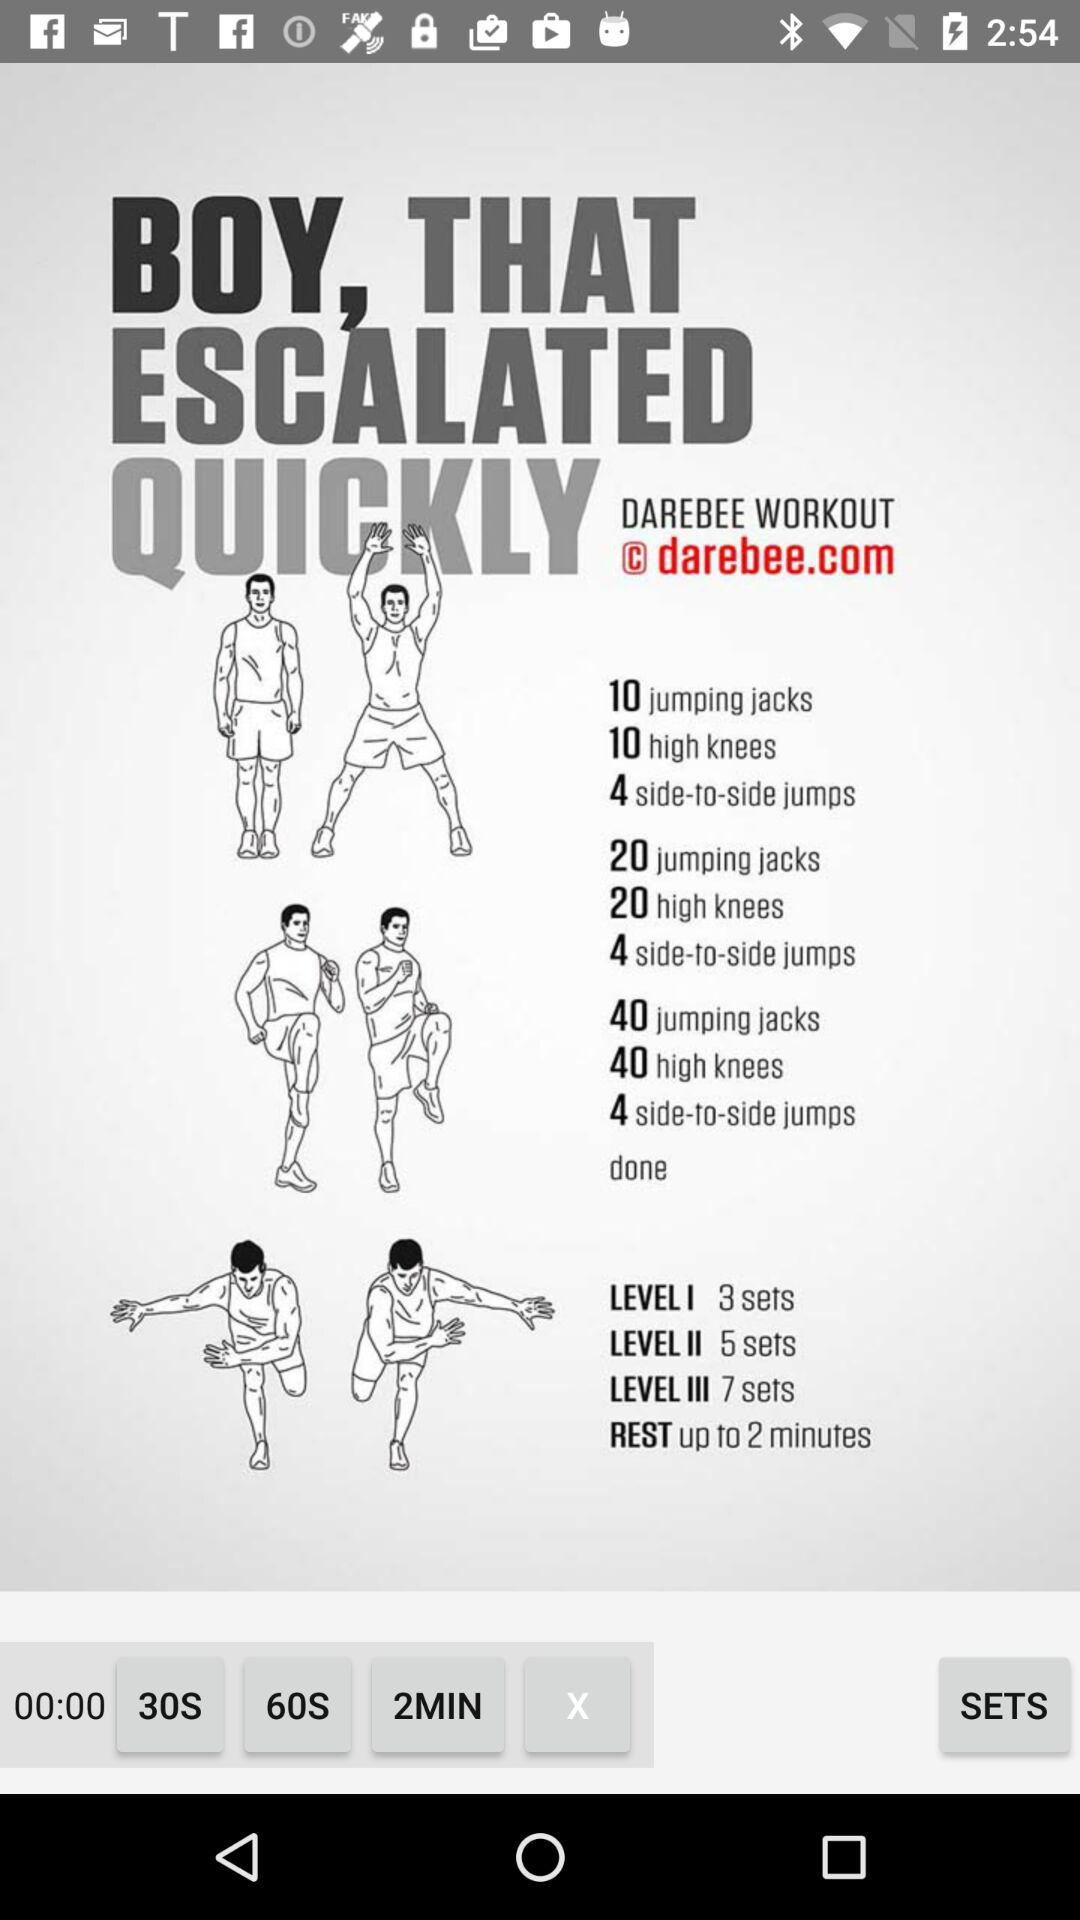What is the workout name? The workout name is "DAREBEE". 